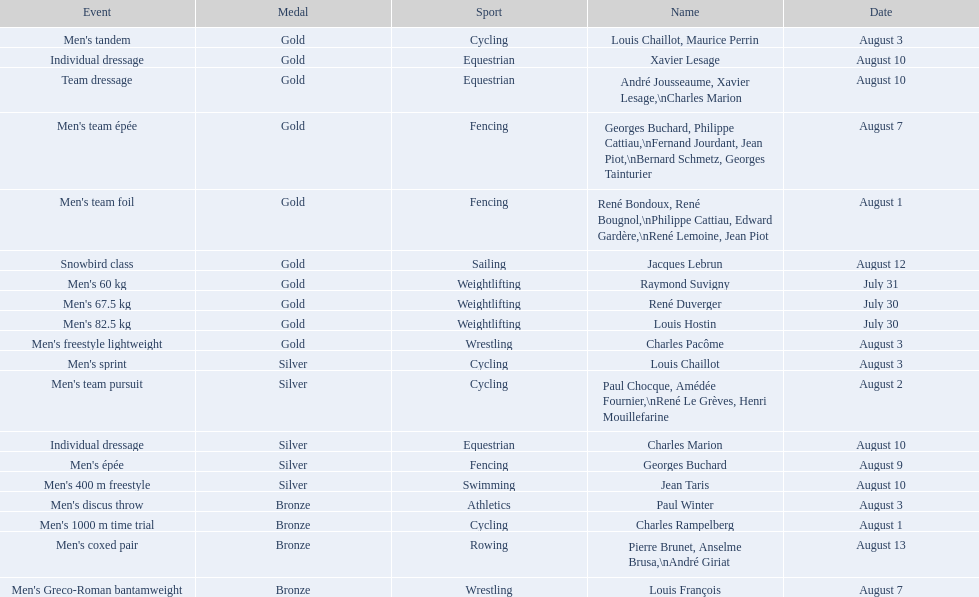How many total gold medals were won by weightlifting? 3. 